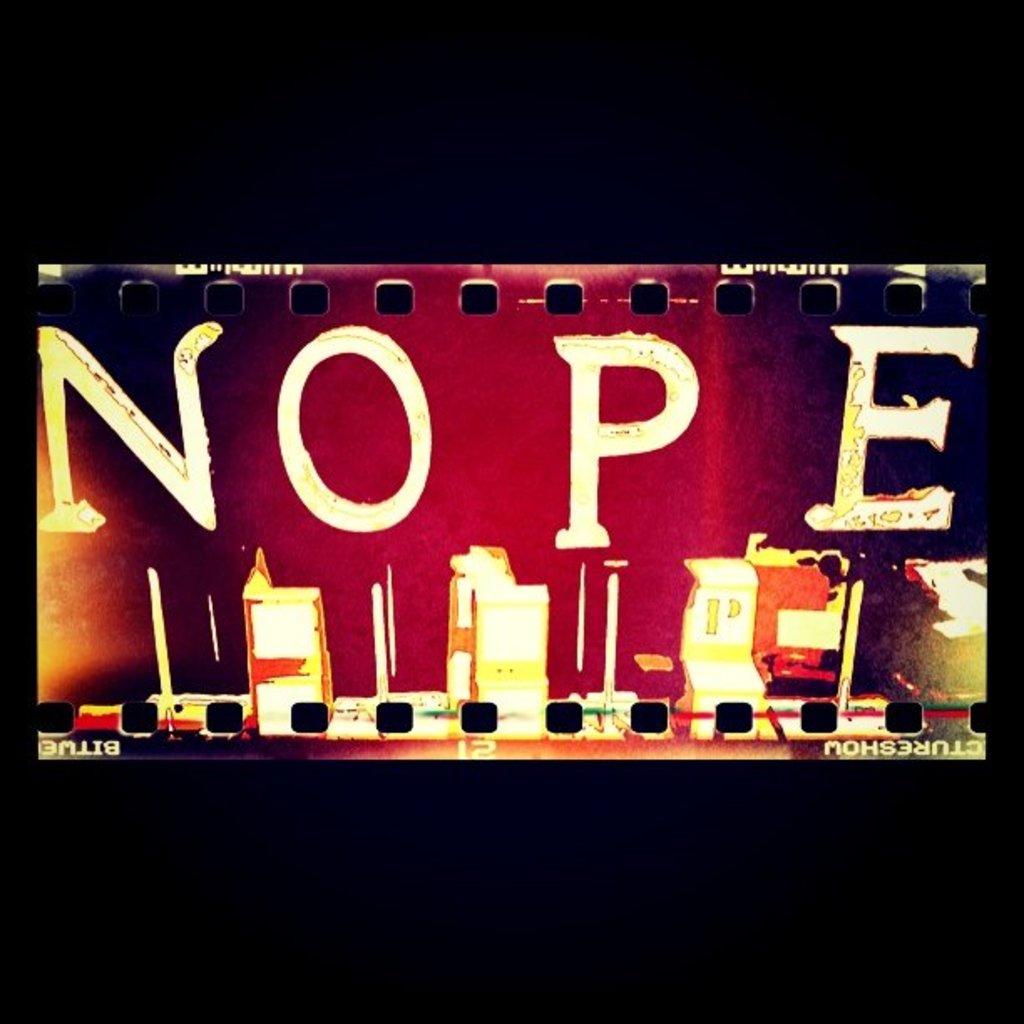What word is written on this film?
Your answer should be very brief. Nope. Can we learn anything from the text?
Offer a terse response. Nope. 